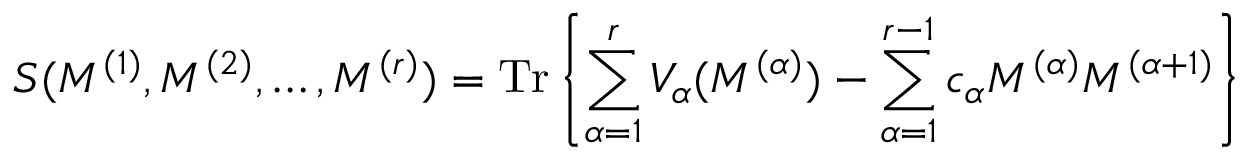Convert formula to latex. <formula><loc_0><loc_0><loc_500><loc_500>S ( M ^ { ( 1 ) } , M ^ { ( 2 ) } , \dots , M ^ { ( r ) } ) = T r \left \{ \sum _ { \alpha = 1 } ^ { r } V _ { \alpha } ( M ^ { ( \alpha ) } ) - \sum _ { \alpha = 1 } ^ { r - 1 } c _ { \alpha } M ^ { ( \alpha ) } M ^ { ( \alpha + 1 ) } \right \}</formula> 